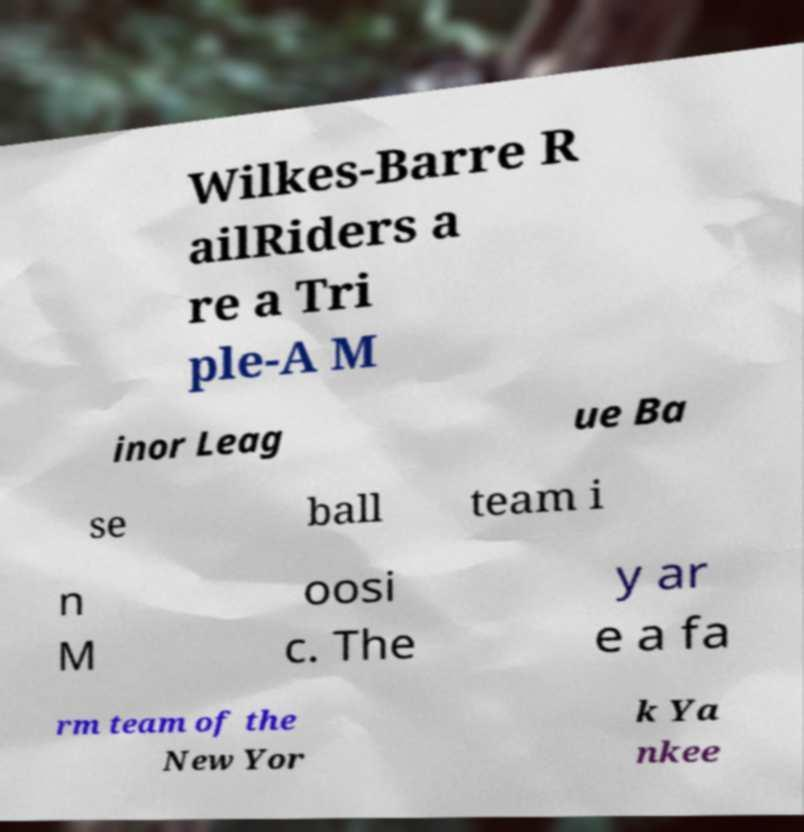Can you accurately transcribe the text from the provided image for me? Wilkes-Barre R ailRiders a re a Tri ple-A M inor Leag ue Ba se ball team i n M oosi c. The y ar e a fa rm team of the New Yor k Ya nkee 